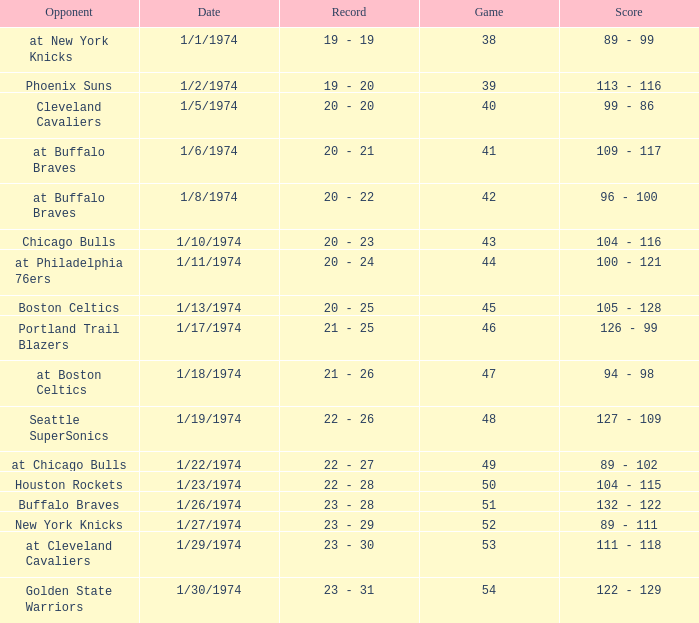What was the score on 1/10/1974? 104 - 116. Help me parse the entirety of this table. {'header': ['Opponent', 'Date', 'Record', 'Game', 'Score'], 'rows': [['at New York Knicks', '1/1/1974', '19 - 19', '38', '89 - 99'], ['Phoenix Suns', '1/2/1974', '19 - 20', '39', '113 - 116'], ['Cleveland Cavaliers', '1/5/1974', '20 - 20', '40', '99 - 86'], ['at Buffalo Braves', '1/6/1974', '20 - 21', '41', '109 - 117'], ['at Buffalo Braves', '1/8/1974', '20 - 22', '42', '96 - 100'], ['Chicago Bulls', '1/10/1974', '20 - 23', '43', '104 - 116'], ['at Philadelphia 76ers', '1/11/1974', '20 - 24', '44', '100 - 121'], ['Boston Celtics', '1/13/1974', '20 - 25', '45', '105 - 128'], ['Portland Trail Blazers', '1/17/1974', '21 - 25', '46', '126 - 99'], ['at Boston Celtics', '1/18/1974', '21 - 26', '47', '94 - 98'], ['Seattle SuperSonics', '1/19/1974', '22 - 26', '48', '127 - 109'], ['at Chicago Bulls', '1/22/1974', '22 - 27', '49', '89 - 102'], ['Houston Rockets', '1/23/1974', '22 - 28', '50', '104 - 115'], ['Buffalo Braves', '1/26/1974', '23 - 28', '51', '132 - 122'], ['New York Knicks', '1/27/1974', '23 - 29', '52', '89 - 111'], ['at Cleveland Cavaliers', '1/29/1974', '23 - 30', '53', '111 - 118'], ['Golden State Warriors', '1/30/1974', '23 - 31', '54', '122 - 129']]} 